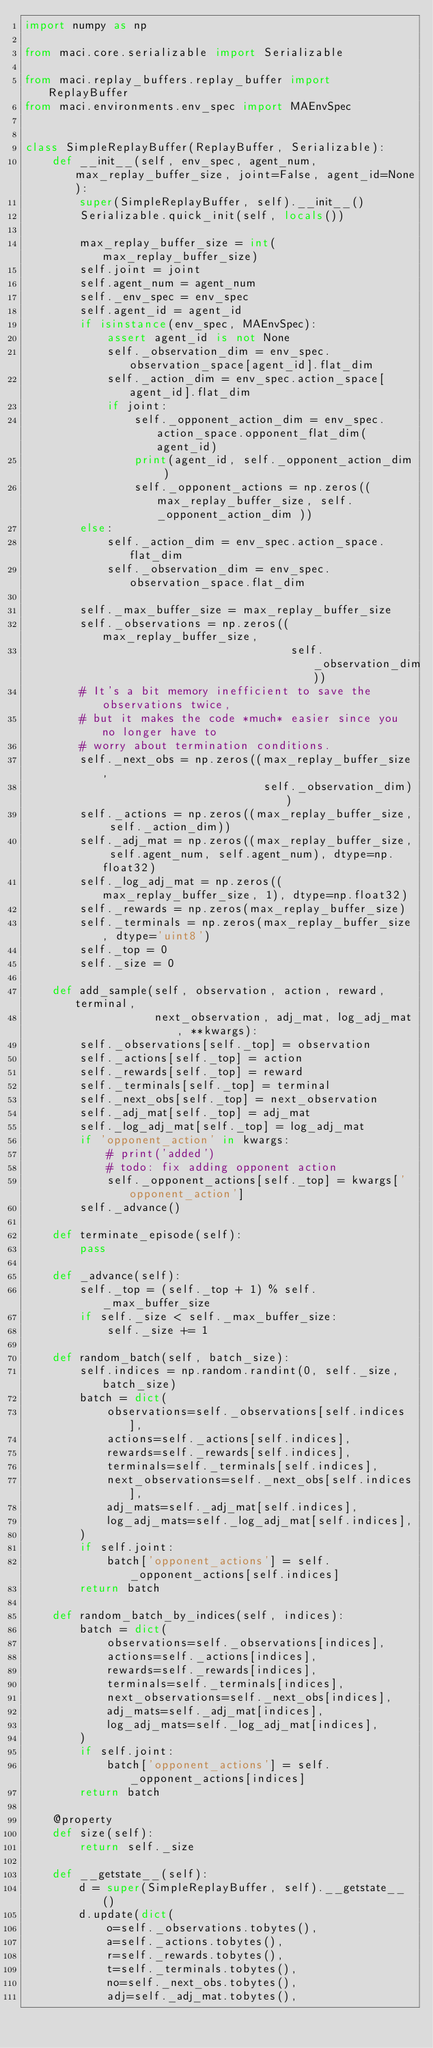Convert code to text. <code><loc_0><loc_0><loc_500><loc_500><_Python_>import numpy as np

from maci.core.serializable import Serializable

from maci.replay_buffers.replay_buffer import ReplayBuffer
from maci.environments.env_spec import MAEnvSpec


class SimpleReplayBuffer(ReplayBuffer, Serializable):
    def __init__(self, env_spec, agent_num, max_replay_buffer_size, joint=False, agent_id=None):
        super(SimpleReplayBuffer, self).__init__()
        Serializable.quick_init(self, locals())

        max_replay_buffer_size = int(max_replay_buffer_size)
        self.joint = joint
        self.agent_num = agent_num
        self._env_spec = env_spec
        self.agent_id = agent_id
        if isinstance(env_spec, MAEnvSpec):
            assert agent_id is not None
            self._observation_dim = env_spec.observation_space[agent_id].flat_dim
            self._action_dim = env_spec.action_space[agent_id].flat_dim
            if joint:
                self._opponent_action_dim = env_spec.action_space.opponent_flat_dim(agent_id)
                print(agent_id, self._opponent_action_dim )
                self._opponent_actions = np.zeros((max_replay_buffer_size, self._opponent_action_dim ))
        else:
            self._action_dim = env_spec.action_space.flat_dim
            self._observation_dim = env_spec.observation_space.flat_dim

        self._max_buffer_size = max_replay_buffer_size
        self._observations = np.zeros((max_replay_buffer_size,
                                       self._observation_dim))
        # It's a bit memory inefficient to save the observations twice,
        # but it makes the code *much* easier since you no longer have to
        # worry about termination conditions.
        self._next_obs = np.zeros((max_replay_buffer_size,
                                   self._observation_dim))
        self._actions = np.zeros((max_replay_buffer_size, self._action_dim))
        self._adj_mat = np.zeros((max_replay_buffer_size, self.agent_num, self.agent_num), dtype=np.float32)    
        self._log_adj_mat = np.zeros((max_replay_buffer_size, 1), dtype=np.float32) 
        self._rewards = np.zeros(max_replay_buffer_size)
        self._terminals = np.zeros(max_replay_buffer_size, dtype='uint8')
        self._top = 0
        self._size = 0

    def add_sample(self, observation, action, reward, terminal,
                   next_observation, adj_mat, log_adj_mat, **kwargs):
        self._observations[self._top] = observation
        self._actions[self._top] = action
        self._rewards[self._top] = reward
        self._terminals[self._top] = terminal
        self._next_obs[self._top] = next_observation
        self._adj_mat[self._top] = adj_mat
        self._log_adj_mat[self._top] = log_adj_mat
        if 'opponent_action' in kwargs:
            # print('added')
            # todo: fix adding opponent action
            self._opponent_actions[self._top] = kwargs['opponent_action']
        self._advance()

    def terminate_episode(self):
        pass

    def _advance(self):
        self._top = (self._top + 1) % self._max_buffer_size
        if self._size < self._max_buffer_size:
            self._size += 1

    def random_batch(self, batch_size):
        self.indices = np.random.randint(0, self._size, batch_size)
        batch = dict(
            observations=self._observations[self.indices],
            actions=self._actions[self.indices],
            rewards=self._rewards[self.indices],
            terminals=self._terminals[self.indices],
            next_observations=self._next_obs[self.indices],
            adj_mats=self._adj_mat[self.indices],
            log_adj_mats=self._log_adj_mat[self.indices],
        )
        if self.joint:
            batch['opponent_actions'] = self._opponent_actions[self.indices]
        return batch

    def random_batch_by_indices(self, indices):
        batch = dict(
            observations=self._observations[indices],
            actions=self._actions[indices],
            rewards=self._rewards[indices],
            terminals=self._terminals[indices],
            next_observations=self._next_obs[indices],
            adj_mats=self._adj_mat[indices],
            log_adj_mats=self._log_adj_mat[indices],
        )
        if self.joint:
            batch['opponent_actions'] = self._opponent_actions[indices]
        return batch

    @property
    def size(self):
        return self._size

    def __getstate__(self):
        d = super(SimpleReplayBuffer, self).__getstate__()
        d.update(dict(
            o=self._observations.tobytes(),
            a=self._actions.tobytes(),
            r=self._rewards.tobytes(),
            t=self._terminals.tobytes(),
            no=self._next_obs.tobytes(),
            adj=self._adj_mat.tobytes(),</code> 